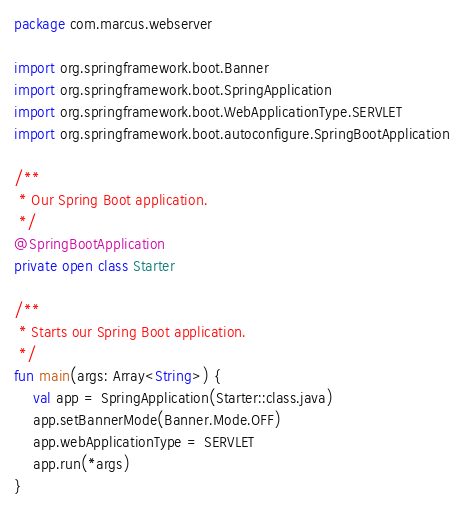Convert code to text. <code><loc_0><loc_0><loc_500><loc_500><_Kotlin_>package com.marcus.webserver

import org.springframework.boot.Banner
import org.springframework.boot.SpringApplication
import org.springframework.boot.WebApplicationType.SERVLET
import org.springframework.boot.autoconfigure.SpringBootApplication

/**
 * Our Spring Boot application.
 */
@SpringBootApplication
private open class Starter

/**
 * Starts our Spring Boot application.
 */
fun main(args: Array<String>) {
    val app = SpringApplication(Starter::class.java)
    app.setBannerMode(Banner.Mode.OFF)
    app.webApplicationType = SERVLET
    app.run(*args)
}
</code> 